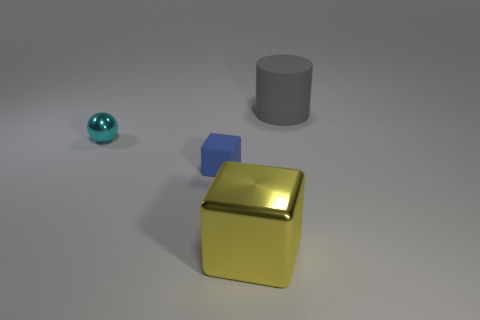How does the lighting in this scene affect the appearance of the objects? The lighting casts soft shadows and highlights on the objects, creating a sense of depth and three-dimensionality. It accentuates the texture of the surfaces, like the smoothness of the ball and the reflective quality of the yellow block. 